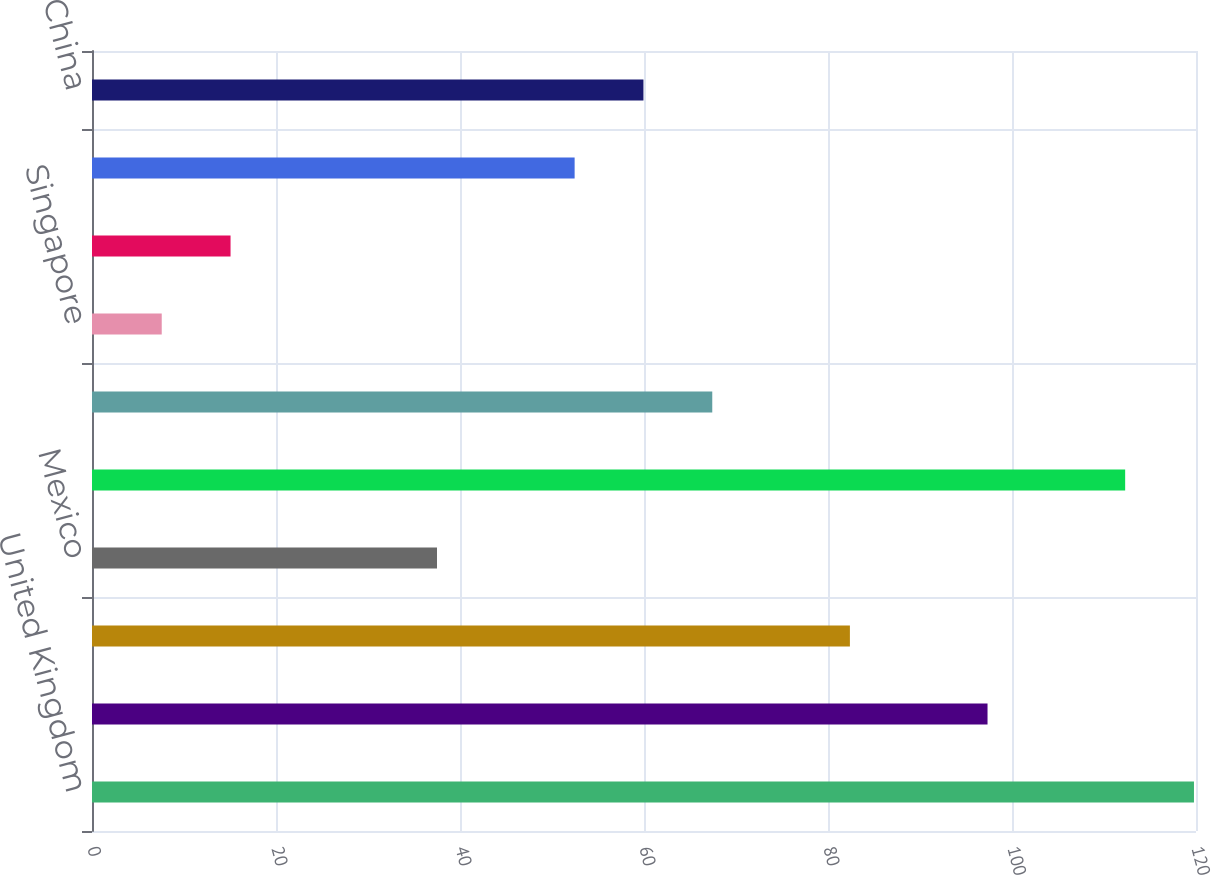Convert chart to OTSL. <chart><loc_0><loc_0><loc_500><loc_500><bar_chart><fcel>United Kingdom<fcel>Germany<fcel>Japan<fcel>Mexico<fcel>France<fcel>South Korea<fcel>Singapore<fcel>India<fcel>Australia<fcel>China<nl><fcel>119.78<fcel>97.34<fcel>82.38<fcel>37.5<fcel>112.3<fcel>67.42<fcel>7.58<fcel>15.06<fcel>52.46<fcel>59.94<nl></chart> 